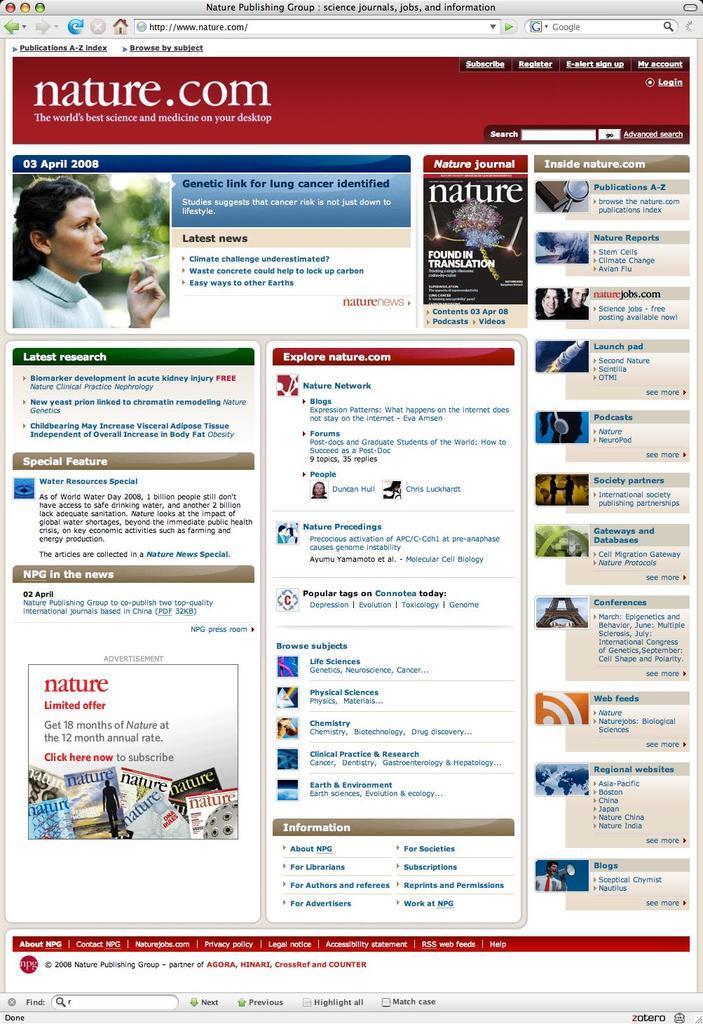In one or two sentences, can you explain what this image depicts? This image looks like a screenshot there are depictions of people on the left and on the right corner. And there is text. 